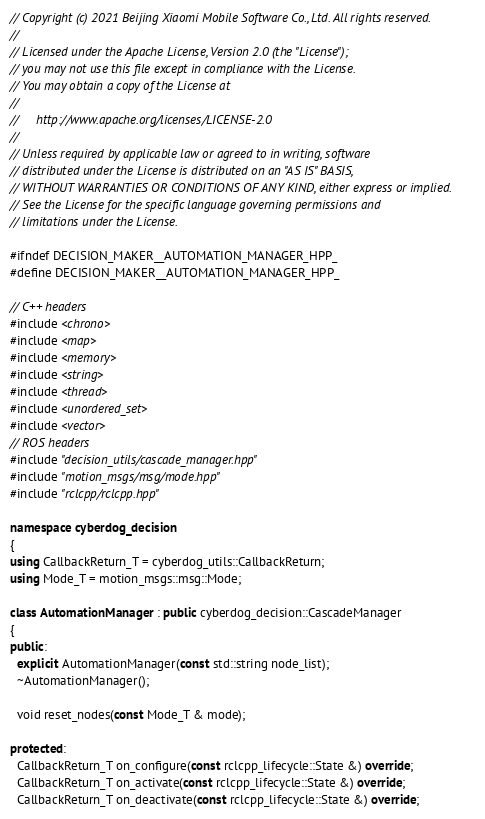Convert code to text. <code><loc_0><loc_0><loc_500><loc_500><_C++_>// Copyright (c) 2021 Beijing Xiaomi Mobile Software Co., Ltd. All rights reserved.
//
// Licensed under the Apache License, Version 2.0 (the "License");
// you may not use this file except in compliance with the License.
// You may obtain a copy of the License at
//
//     http://www.apache.org/licenses/LICENSE-2.0
//
// Unless required by applicable law or agreed to in writing, software
// distributed under the License is distributed on an "AS IS" BASIS,
// WITHOUT WARRANTIES OR CONDITIONS OF ANY KIND, either express or implied.
// See the License for the specific language governing permissions and
// limitations under the License.

#ifndef DECISION_MAKER__AUTOMATION_MANAGER_HPP_
#define DECISION_MAKER__AUTOMATION_MANAGER_HPP_

// C++ headers
#include <chrono>
#include <map>
#include <memory>
#include <string>
#include <thread>
#include <unordered_set>
#include <vector>
// ROS headers
#include "decision_utils/cascade_manager.hpp"
#include "motion_msgs/msg/mode.hpp"
#include "rclcpp/rclcpp.hpp"

namespace cyberdog_decision
{
using CallbackReturn_T = cyberdog_utils::CallbackReturn;
using Mode_T = motion_msgs::msg::Mode;

class AutomationManager : public cyberdog_decision::CascadeManager
{
public:
  explicit AutomationManager(const std::string node_list);
  ~AutomationManager();

  void reset_nodes(const Mode_T & mode);

protected:
  CallbackReturn_T on_configure(const rclcpp_lifecycle::State &) override;
  CallbackReturn_T on_activate(const rclcpp_lifecycle::State &) override;
  CallbackReturn_T on_deactivate(const rclcpp_lifecycle::State &) override;</code> 